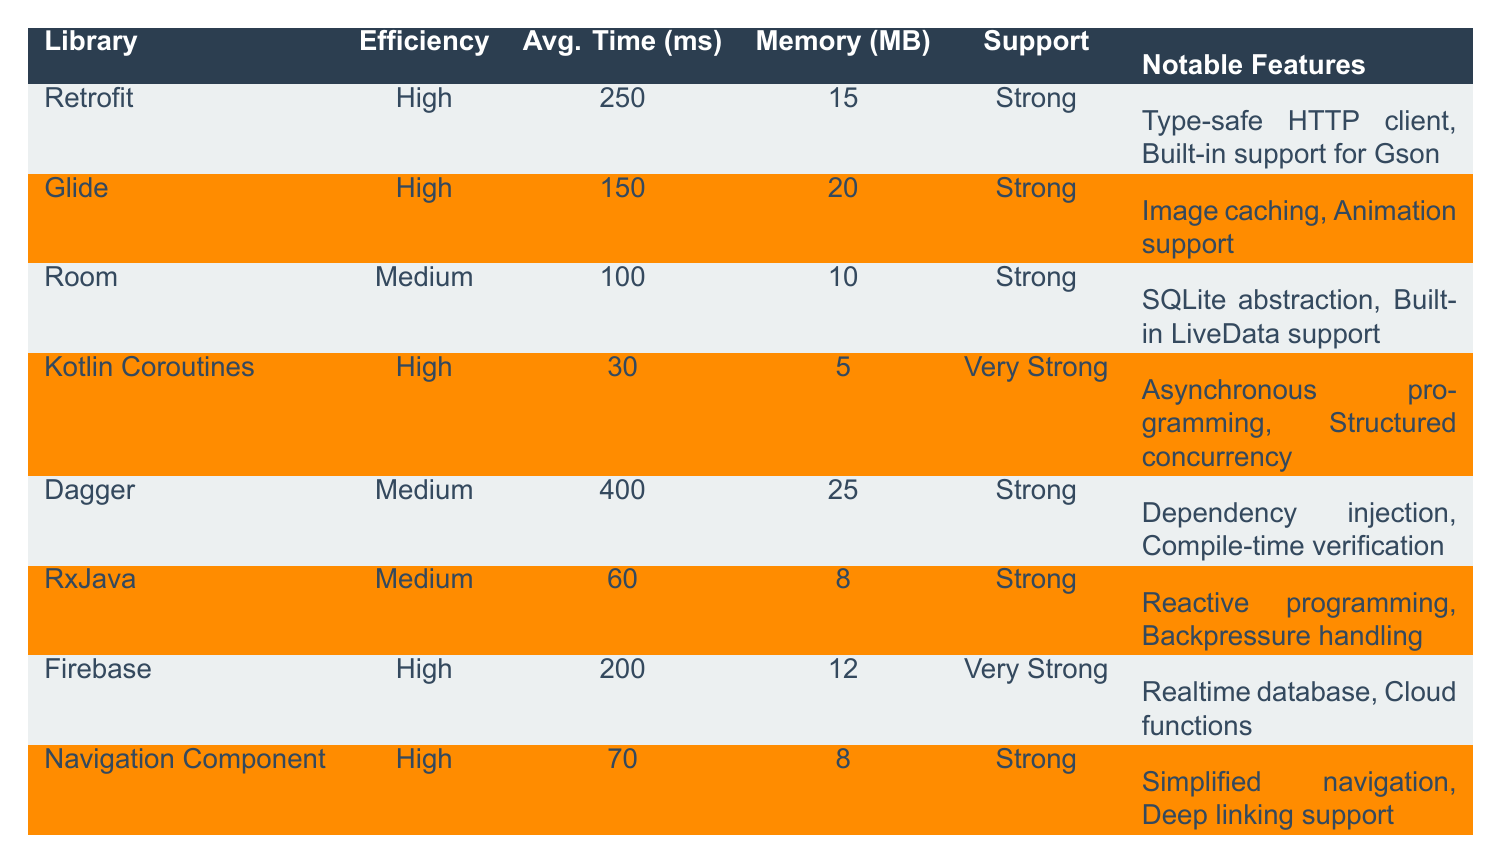What is the average response time for the Retrofit library? The average response time for the Retrofit library is listed in the table as 250 milliseconds.
Answer: 250 ms Which library has the lowest memory usage? Examining the memory usage column, the Kotlin Coroutines library has the lowest memory usage at 5 MB.
Answer: 5 MB Is the community support for Firebase strong? The table indicates that Firebase has "Very Strong" community support, thus confirming the fact.
Answer: Yes How much faster is Kotlin Coroutines compared to Room based on average context switch/query times? The average context switch time for Kotlin Coroutines is 30 ms and for Room it is 100 ms. The difference is 100 - 30 = 70 ms, indicating Kotlin Coroutines is 70 ms faster.
Answer: 70 ms How many libraries have high development efficiency? By reviewing the development efficiency column, there are four libraries (Retrofit, Glide, Kotlin Coroutines, Firebase, Navigation Component) marked as high efficiency.
Answer: 5 libraries What is the total average time for the libraries that have "Medium" development efficiency? The average times for the medium libraries are Dagger (400 ms), Room (100 ms), and RxJava (60 ms). The total is 400 + 100 + 60 = 560 ms. Divide by 3 for the average: 560/3 = approximately 186.67 ms.
Answer: 186.67 ms Does Glide have a notable feature for image caching? The notable features for Glide listed in the table include image caching, confirming the fact.
Answer: Yes Which library has the highest average compilation time and what is it? The Dagger library has the highest average compilation time at 400 ms as stated in the average compilation time column.
Answer: 400 ms What is the average memory usage of the libraries with high development efficiency? Memory usages for high efficiency libraries are Retrofit (15 MB), Glide (20 MB), Kotlin Coroutines (5 MB), Firebase (12 MB), and Navigation Component (8 MB). Adding these gives 15 + 20 + 5 + 12 + 8 = 60 MB. The average is 60/5 = 12 MB.
Answer: 12 MB Which library has both average query time and average memory usage lower than the average for the overall data? The library Room has an average query time of 100 ms and memory usage of 10 MB, which are both below the averages of 186.67 ms and 12.5 MB calculated from the rest, confirming it fits the criteria.
Answer: Room 